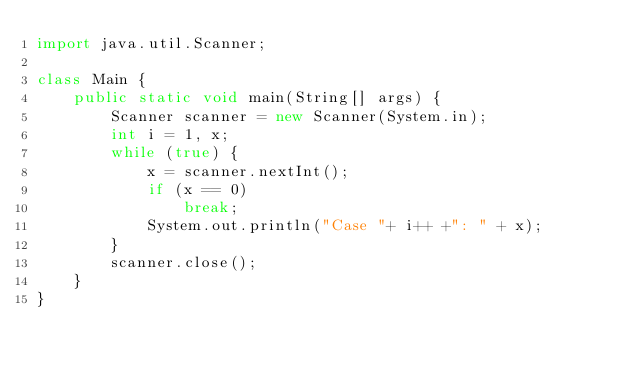Convert code to text. <code><loc_0><loc_0><loc_500><loc_500><_Java_>import java.util.Scanner;

class Main {
	public static void main(String[] args) {
		Scanner scanner = new Scanner(System.in);
		int i = 1, x;
		while (true) {
			x = scanner.nextInt();
			if (x == 0)
				break;
			System.out.println("Case "+ i++ +": " + x);
		}
		scanner.close();
	}
}</code> 